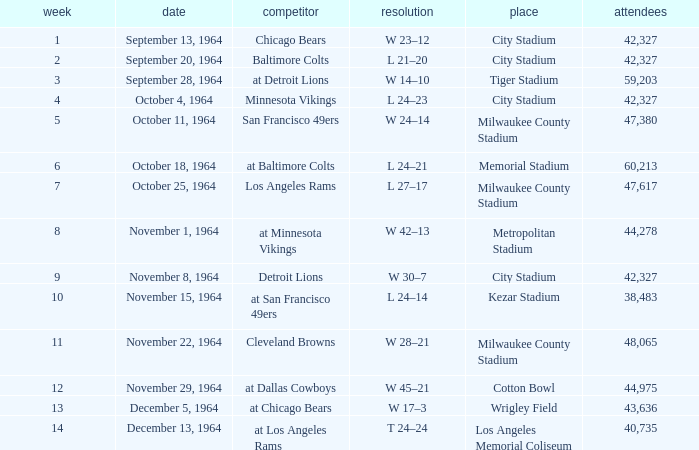What is the average attendance at a week 4 game? 42327.0. 